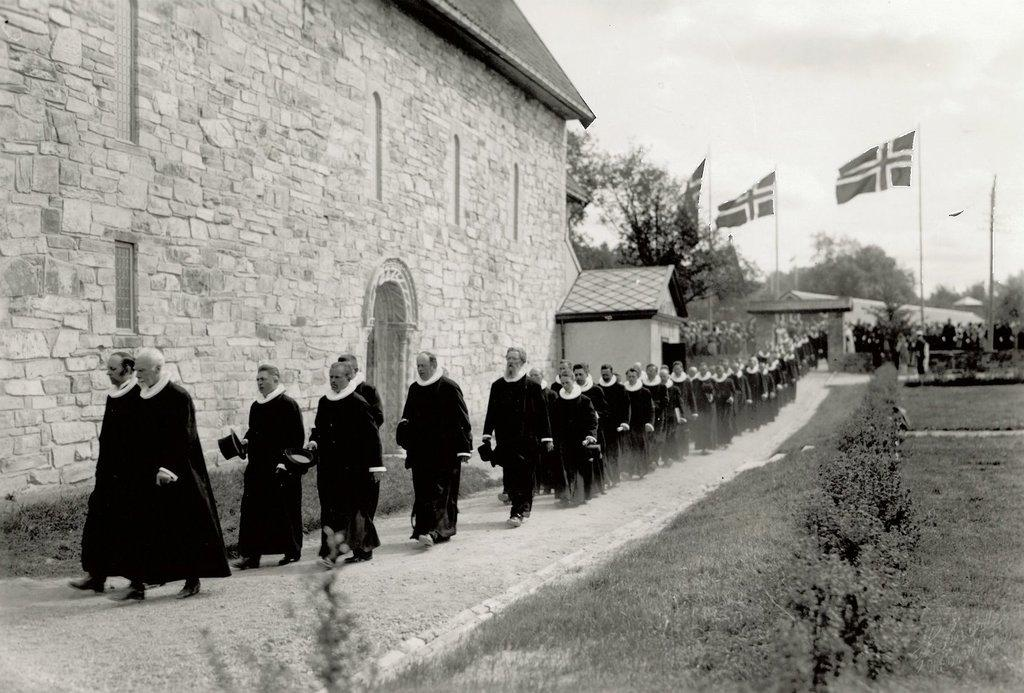What type of structures can be seen in the image? There are houses in the image. What additional objects are present in the image? There are flags, trees, people, plants, and grass in the image. Can you describe the natural elements in the image? There are trees, plants, and grass in the image. How many types of living organisms can be seen in the image? There are people and plants in the image. What type of bone can be seen in the image? There is no bone present in the image. How many mice are visible in the image? There are no mice present in the image. 